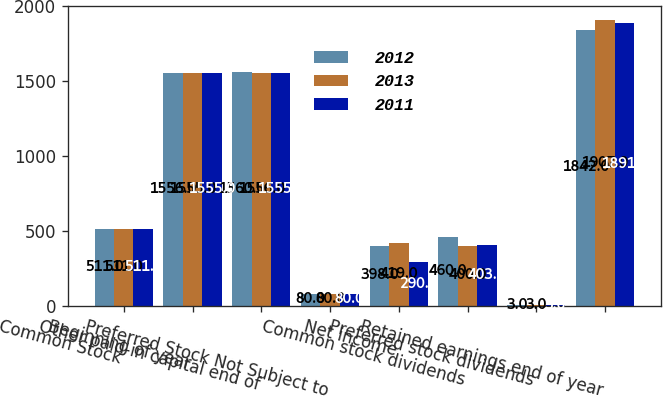Convert chart to OTSL. <chart><loc_0><loc_0><loc_500><loc_500><stacked_bar_chart><ecel><fcel>Common Stock<fcel>Beginning of year<fcel>Other paid-in capital end of<fcel>Preferred Stock Not Subject to<fcel>Net income<fcel>Common stock dividends<fcel>Preferred stock dividends<fcel>Retained earnings end of year<nl><fcel>2012<fcel>511<fcel>1556<fcel>1560<fcel>80<fcel>398<fcel>460<fcel>3<fcel>1842<nl><fcel>2013<fcel>511<fcel>1555<fcel>1556<fcel>80<fcel>419<fcel>400<fcel>3<fcel>1907<nl><fcel>2011<fcel>511<fcel>1555<fcel>1555<fcel>80<fcel>290<fcel>403<fcel>3<fcel>1891<nl></chart> 